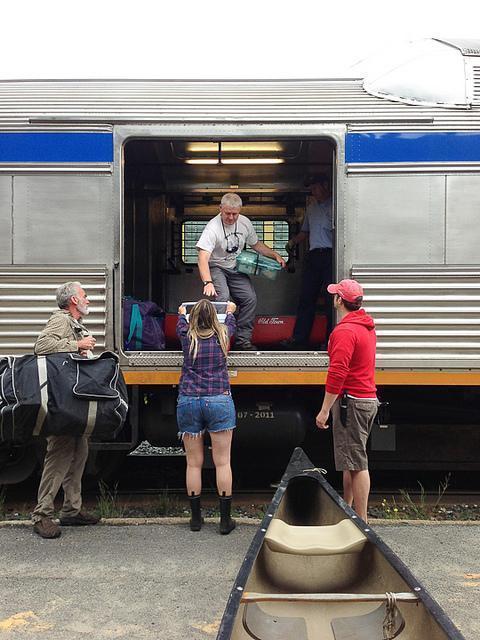What is this type of train car called?
Answer the question by selecting the correct answer among the 4 following choices.
Options: Caboose, passenger, cargo, sleeper. Cargo. 